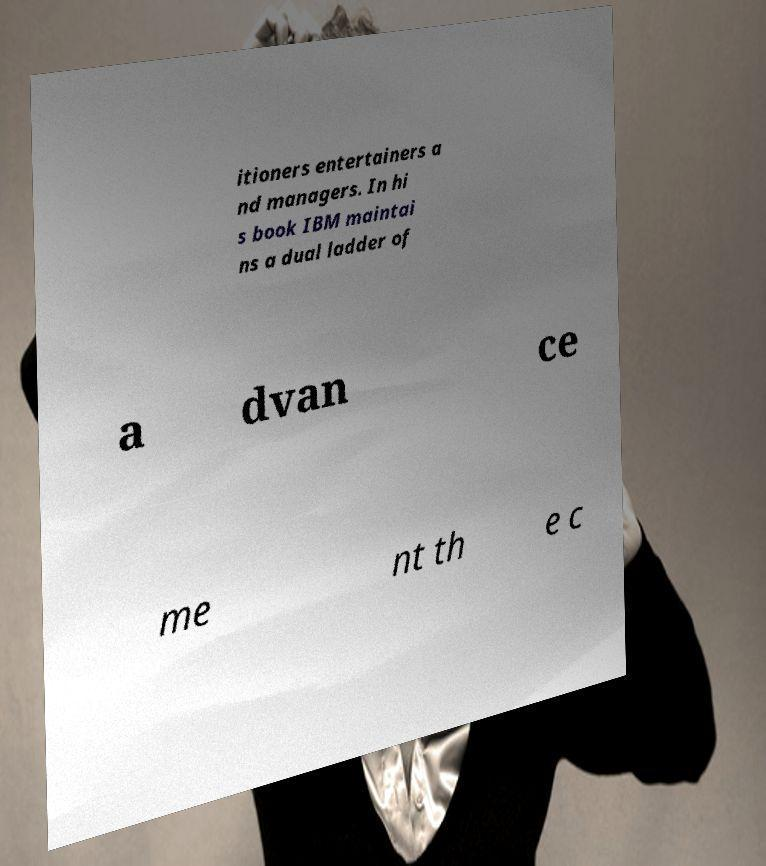Please identify and transcribe the text found in this image. itioners entertainers a nd managers. In hi s book IBM maintai ns a dual ladder of a dvan ce me nt th e c 